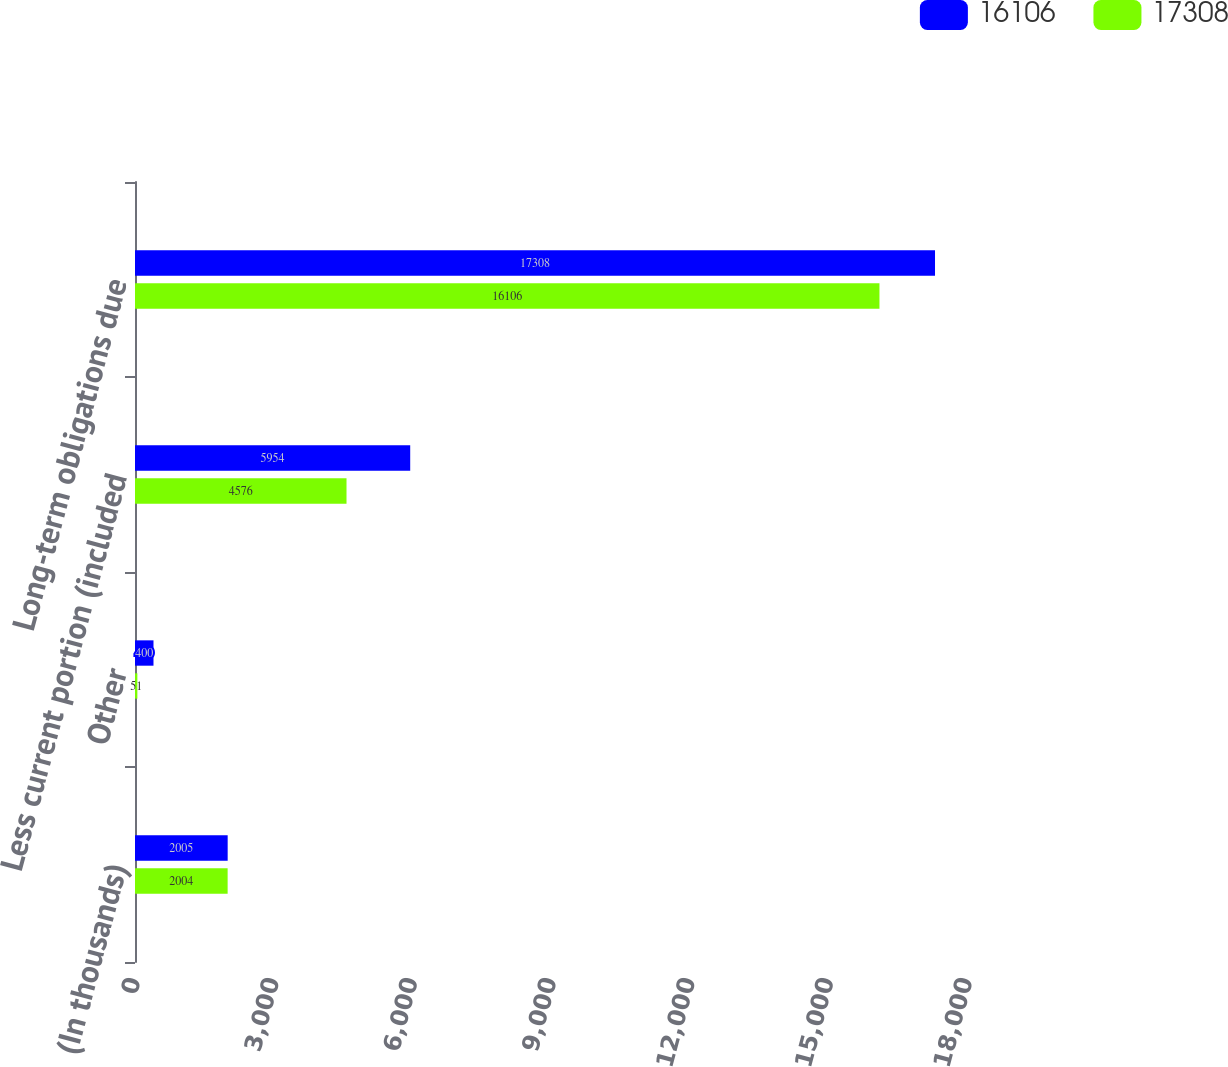<chart> <loc_0><loc_0><loc_500><loc_500><stacked_bar_chart><ecel><fcel>(In thousands)<fcel>Other<fcel>Less current portion (included<fcel>Long-term obligations due<nl><fcel>16106<fcel>2005<fcel>400<fcel>5954<fcel>17308<nl><fcel>17308<fcel>2004<fcel>51<fcel>4576<fcel>16106<nl></chart> 